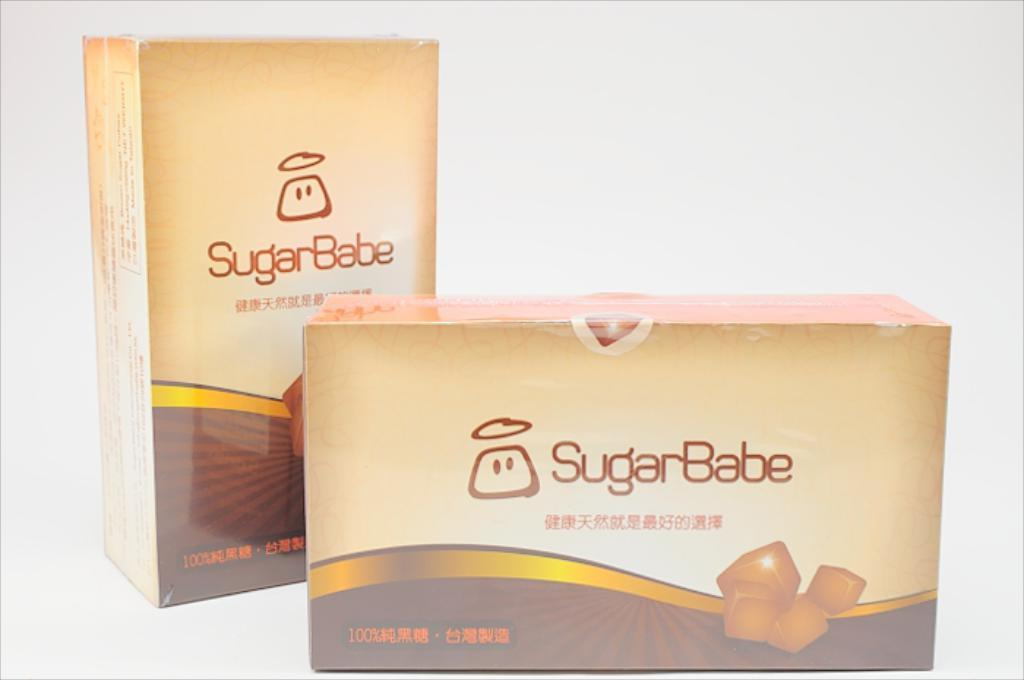Provide a one-sentence caption for the provided image. A Sugarbabe snack sitting next to another one. 